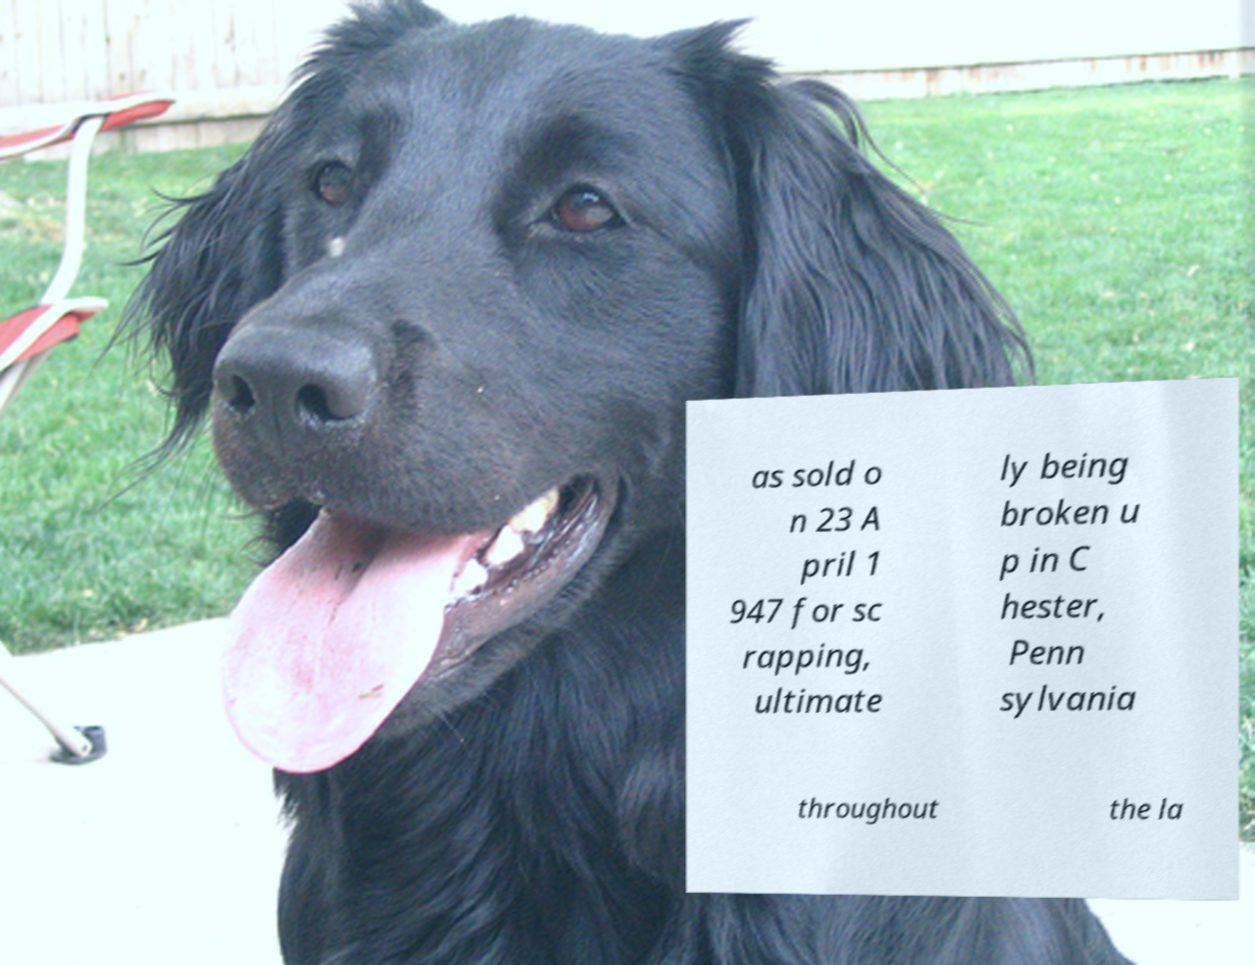Could you assist in decoding the text presented in this image and type it out clearly? as sold o n 23 A pril 1 947 for sc rapping, ultimate ly being broken u p in C hester, Penn sylvania throughout the la 